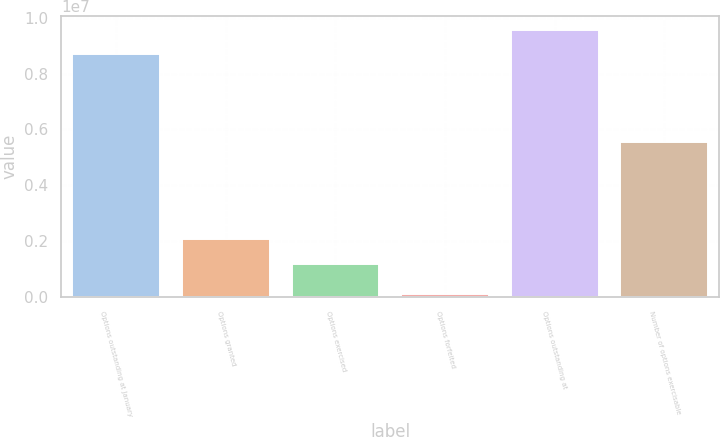Convert chart. <chart><loc_0><loc_0><loc_500><loc_500><bar_chart><fcel>Options outstanding at January<fcel>Options granted<fcel>Options exercised<fcel>Options forfeited<fcel>Options outstanding at<fcel>Number of options exercisable<nl><fcel>8.68287e+06<fcel>2.08235e+06<fcel>1.19089e+06<fcel>114804<fcel>9.57433e+06<fcel>5.56063e+06<nl></chart> 